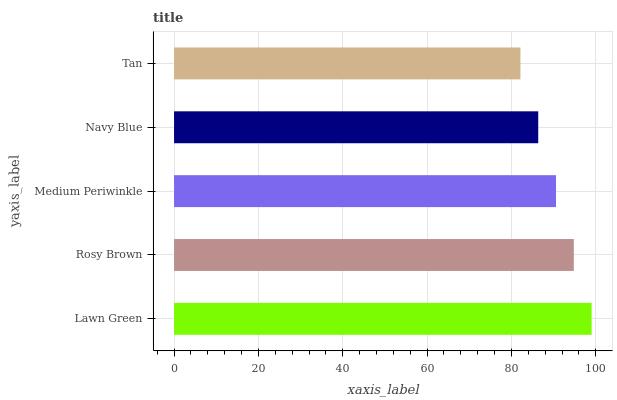Is Tan the minimum?
Answer yes or no. Yes. Is Lawn Green the maximum?
Answer yes or no. Yes. Is Rosy Brown the minimum?
Answer yes or no. No. Is Rosy Brown the maximum?
Answer yes or no. No. Is Lawn Green greater than Rosy Brown?
Answer yes or no. Yes. Is Rosy Brown less than Lawn Green?
Answer yes or no. Yes. Is Rosy Brown greater than Lawn Green?
Answer yes or no. No. Is Lawn Green less than Rosy Brown?
Answer yes or no. No. Is Medium Periwinkle the high median?
Answer yes or no. Yes. Is Medium Periwinkle the low median?
Answer yes or no. Yes. Is Navy Blue the high median?
Answer yes or no. No. Is Tan the low median?
Answer yes or no. No. 